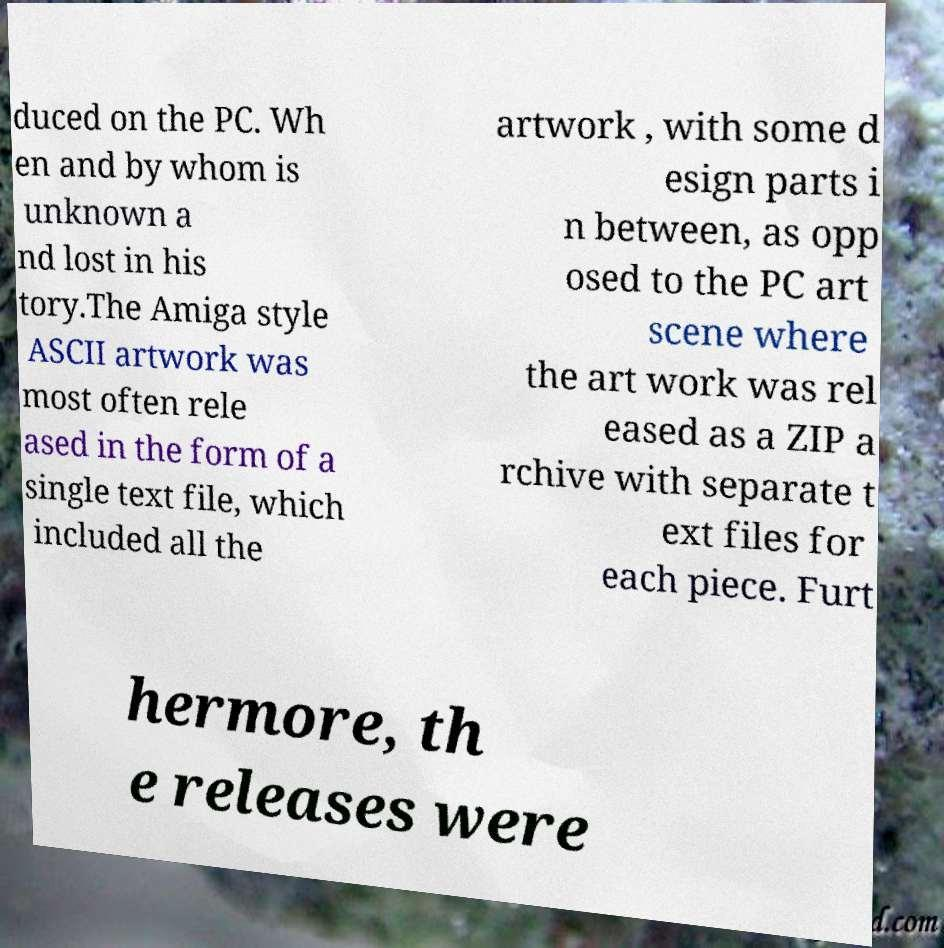There's text embedded in this image that I need extracted. Can you transcribe it verbatim? duced on the PC. Wh en and by whom is unknown a nd lost in his tory.The Amiga style ASCII artwork was most often rele ased in the form of a single text file, which included all the artwork , with some d esign parts i n between, as opp osed to the PC art scene where the art work was rel eased as a ZIP a rchive with separate t ext files for each piece. Furt hermore, th e releases were 